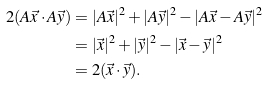<formula> <loc_0><loc_0><loc_500><loc_500>2 ( A \vec { x } \cdot A \vec { y } ) & = | A \vec { x } | ^ { 2 } + | A \vec { y } | ^ { 2 } - | A \vec { x } - A \vec { y } | ^ { 2 } \\ & = | \vec { x } | ^ { 2 } + | \vec { y } | ^ { 2 } - | \vec { x } - \vec { y } | ^ { 2 } \\ & = 2 ( \vec { x } \cdot \vec { y } ) .</formula> 